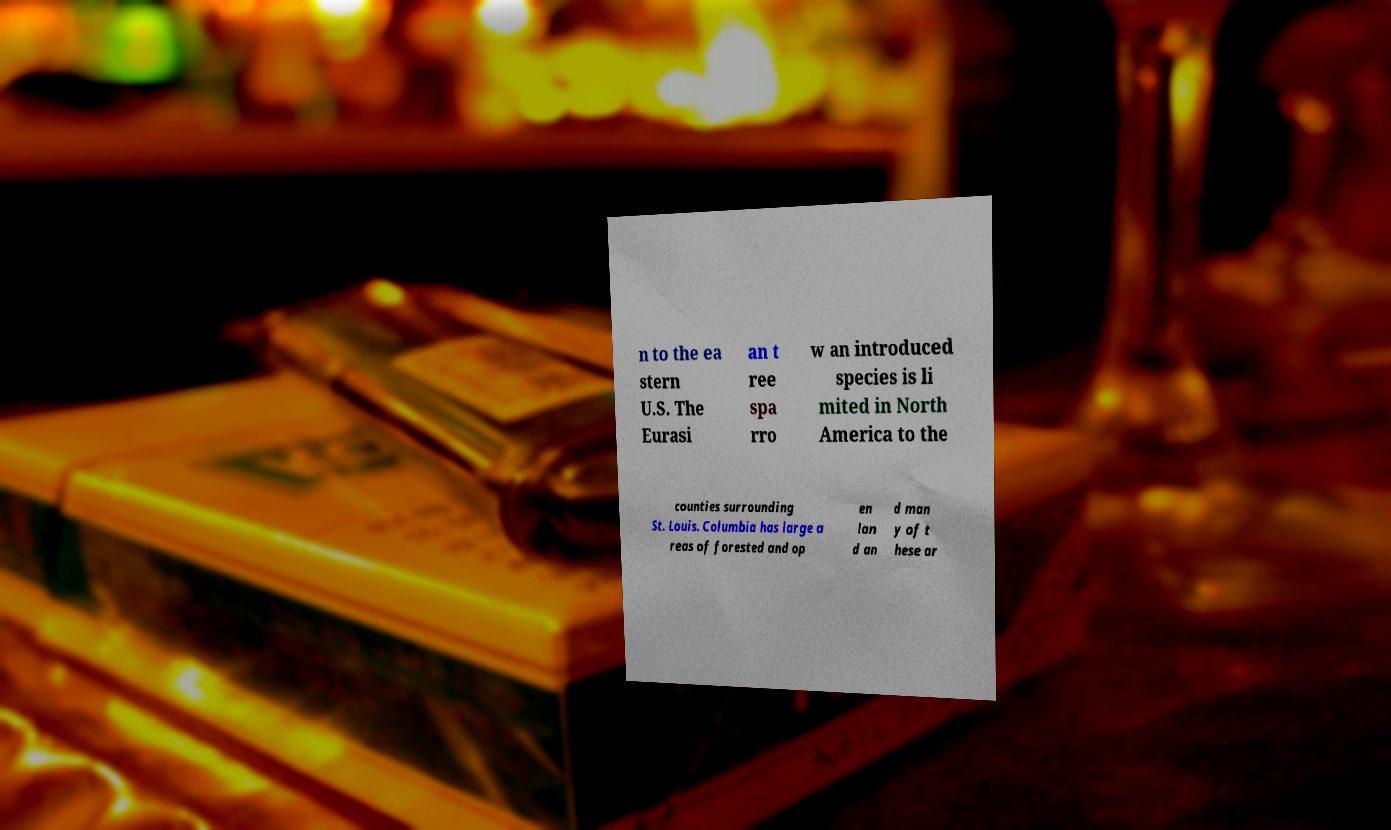Can you read and provide the text displayed in the image?This photo seems to have some interesting text. Can you extract and type it out for me? n to the ea stern U.S. The Eurasi an t ree spa rro w an introduced species is li mited in North America to the counties surrounding St. Louis. Columbia has large a reas of forested and op en lan d an d man y of t hese ar 